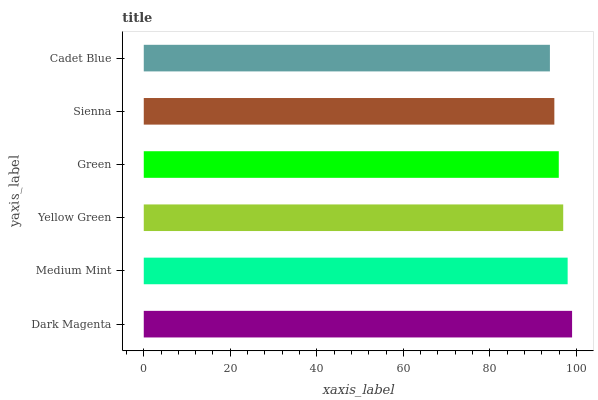Is Cadet Blue the minimum?
Answer yes or no. Yes. Is Dark Magenta the maximum?
Answer yes or no. Yes. Is Medium Mint the minimum?
Answer yes or no. No. Is Medium Mint the maximum?
Answer yes or no. No. Is Dark Magenta greater than Medium Mint?
Answer yes or no. Yes. Is Medium Mint less than Dark Magenta?
Answer yes or no. Yes. Is Medium Mint greater than Dark Magenta?
Answer yes or no. No. Is Dark Magenta less than Medium Mint?
Answer yes or no. No. Is Yellow Green the high median?
Answer yes or no. Yes. Is Green the low median?
Answer yes or no. Yes. Is Medium Mint the high median?
Answer yes or no. No. Is Yellow Green the low median?
Answer yes or no. No. 